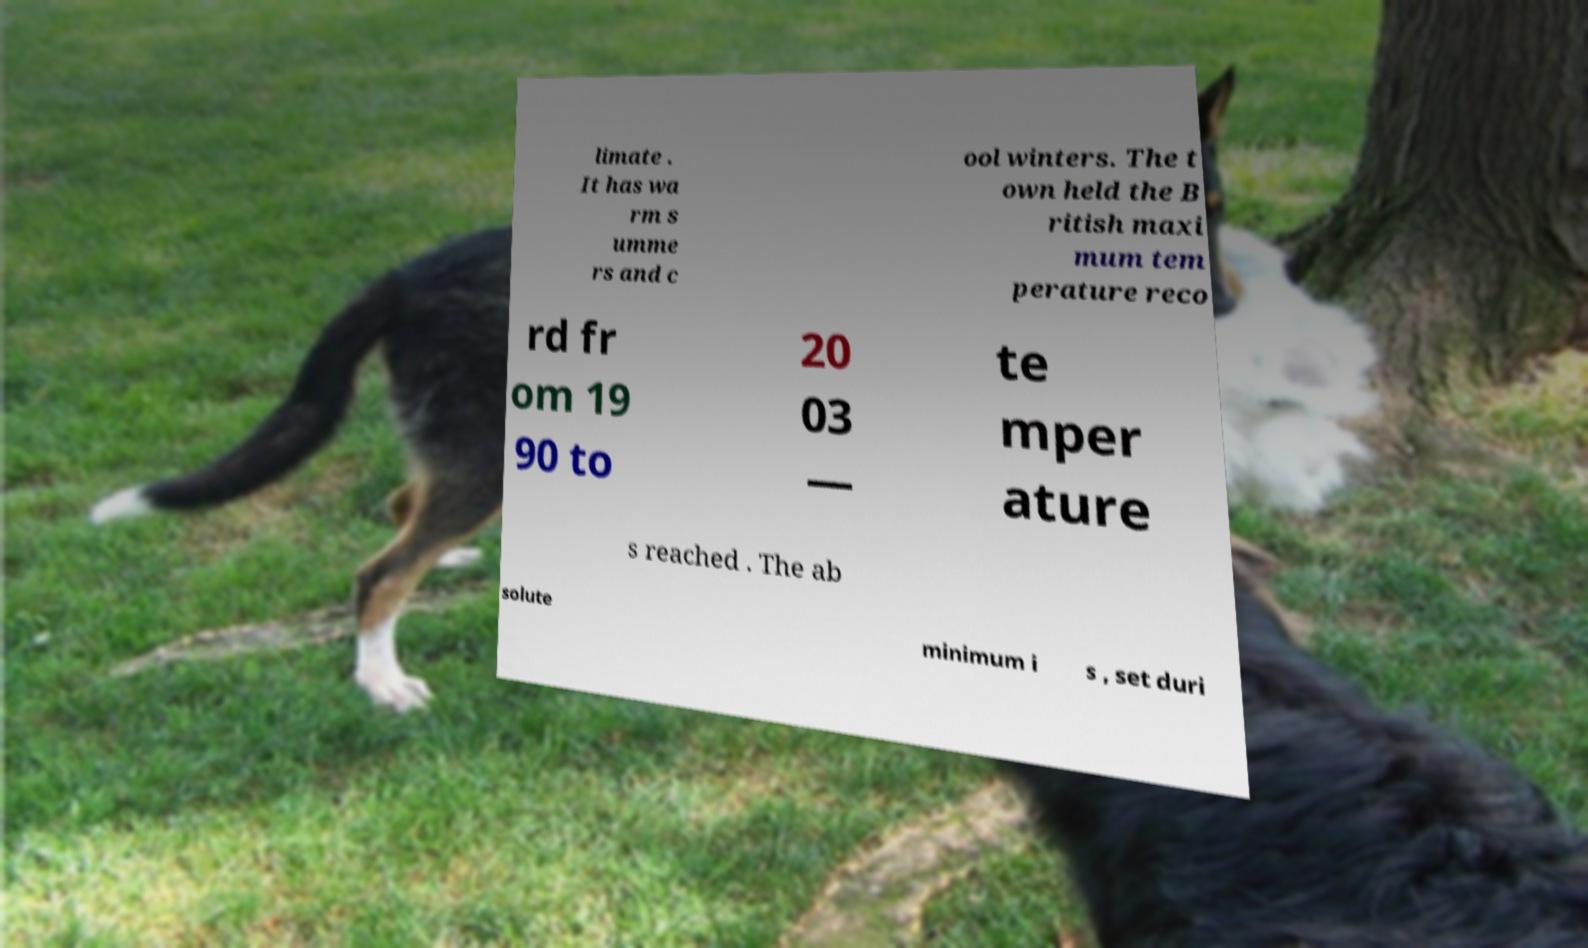I need the written content from this picture converted into text. Can you do that? limate . It has wa rm s umme rs and c ool winters. The t own held the B ritish maxi mum tem perature reco rd fr om 19 90 to 20 03 — te mper ature s reached . The ab solute minimum i s , set duri 